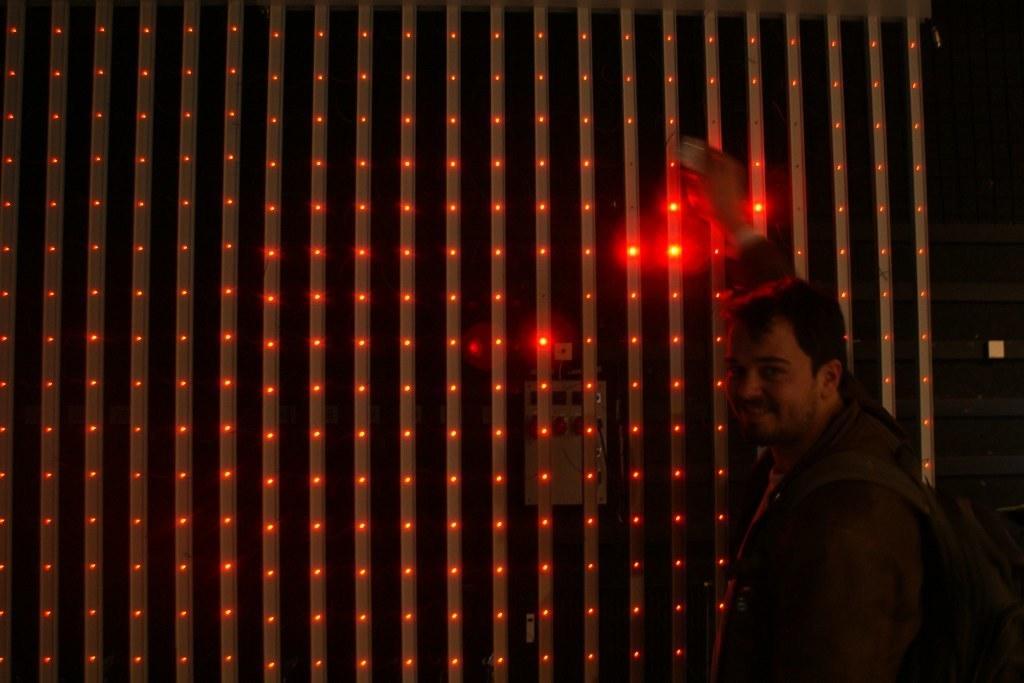Describe this image in one or two sentences. In this image I see a man who is smiling and I see that he is wearing a bag and in the background I see number of red lights. 